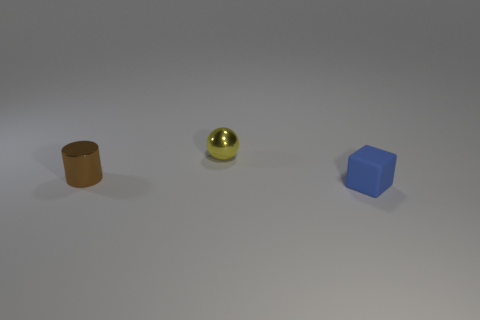Add 1 brown shiny cylinders. How many objects exist? 4 Subtract all large cyan rubber cylinders. Subtract all small yellow shiny things. How many objects are left? 2 Add 3 tiny brown things. How many tiny brown things are left? 4 Add 2 small yellow metal things. How many small yellow metal things exist? 3 Subtract 1 blue cubes. How many objects are left? 2 Subtract all cylinders. How many objects are left? 2 Subtract 1 cubes. How many cubes are left? 0 Subtract all red cylinders. Subtract all green balls. How many cylinders are left? 1 